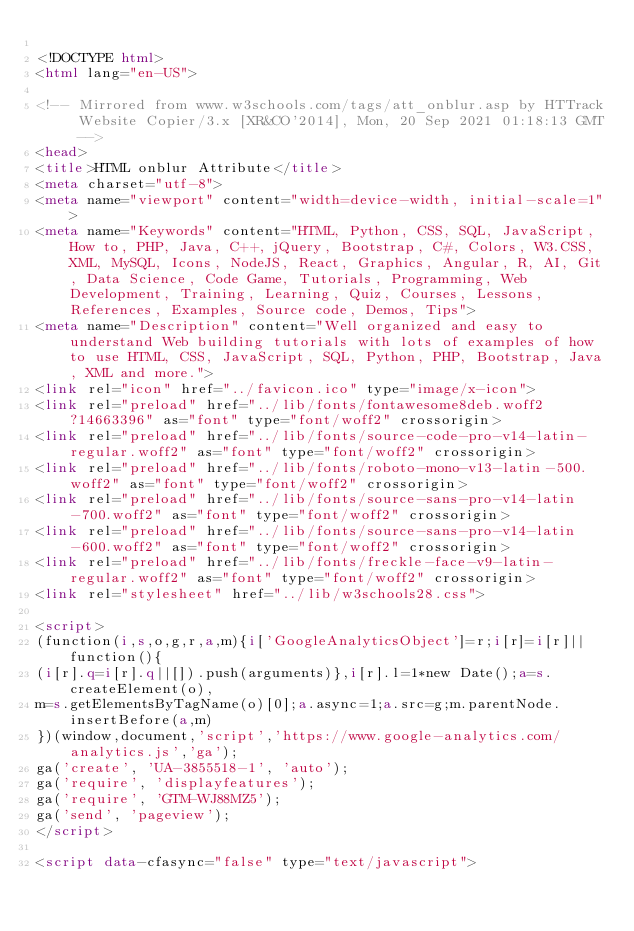Convert code to text. <code><loc_0><loc_0><loc_500><loc_500><_HTML_>
<!DOCTYPE html>
<html lang="en-US">

<!-- Mirrored from www.w3schools.com/tags/att_onblur.asp by HTTrack Website Copier/3.x [XR&CO'2014], Mon, 20 Sep 2021 01:18:13 GMT -->
<head>
<title>HTML onblur Attribute</title>
<meta charset="utf-8">
<meta name="viewport" content="width=device-width, initial-scale=1">
<meta name="Keywords" content="HTML, Python, CSS, SQL, JavaScript, How to, PHP, Java, C++, jQuery, Bootstrap, C#, Colors, W3.CSS, XML, MySQL, Icons, NodeJS, React, Graphics, Angular, R, AI, Git, Data Science, Code Game, Tutorials, Programming, Web Development, Training, Learning, Quiz, Courses, Lessons, References, Examples, Source code, Demos, Tips">
<meta name="Description" content="Well organized and easy to understand Web building tutorials with lots of examples of how to use HTML, CSS, JavaScript, SQL, Python, PHP, Bootstrap, Java, XML and more.">
<link rel="icon" href="../favicon.ico" type="image/x-icon">
<link rel="preload" href="../lib/fonts/fontawesome8deb.woff2?14663396" as="font" type="font/woff2" crossorigin> 
<link rel="preload" href="../lib/fonts/source-code-pro-v14-latin-regular.woff2" as="font" type="font/woff2" crossorigin> 
<link rel="preload" href="../lib/fonts/roboto-mono-v13-latin-500.woff2" as="font" type="font/woff2" crossorigin> 
<link rel="preload" href="../lib/fonts/source-sans-pro-v14-latin-700.woff2" as="font" type="font/woff2" crossorigin> 
<link rel="preload" href="../lib/fonts/source-sans-pro-v14-latin-600.woff2" as="font" type="font/woff2" crossorigin> 
<link rel="preload" href="../lib/fonts/freckle-face-v9-latin-regular.woff2" as="font" type="font/woff2" crossorigin> 
<link rel="stylesheet" href="../lib/w3schools28.css">

<script>
(function(i,s,o,g,r,a,m){i['GoogleAnalyticsObject']=r;i[r]=i[r]||function(){
(i[r].q=i[r].q||[]).push(arguments)},i[r].l=1*new Date();a=s.createElement(o),
m=s.getElementsByTagName(o)[0];a.async=1;a.src=g;m.parentNode.insertBefore(a,m)
})(window,document,'script','https://www.google-analytics.com/analytics.js','ga');
ga('create', 'UA-3855518-1', 'auto');
ga('require', 'displayfeatures');
ga('require', 'GTM-WJ88MZ5');
ga('send', 'pageview');
</script>

<script data-cfasync="false" type="text/javascript"></code> 